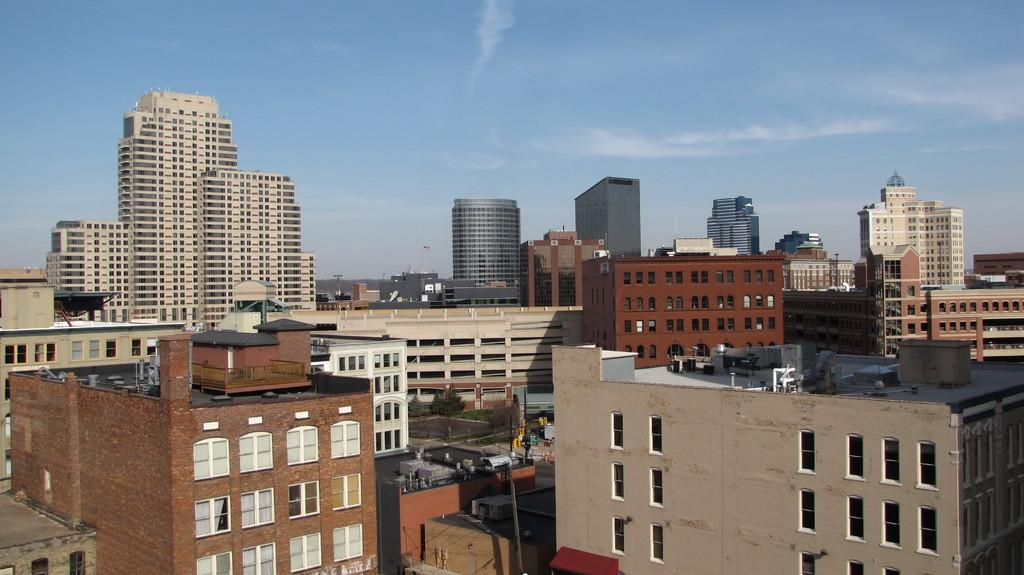What structures can be seen in the image? There are buildings in the image. What part of the natural environment is visible in the image? The sky is visible in the background of the image. What type of dinosaurs can be seen in the image? There are no dinosaurs present in the image; it features buildings and the sky. Who is the manager of the buildings in the image? There is no information about a manager in the image, as it only shows buildings and the sky. 